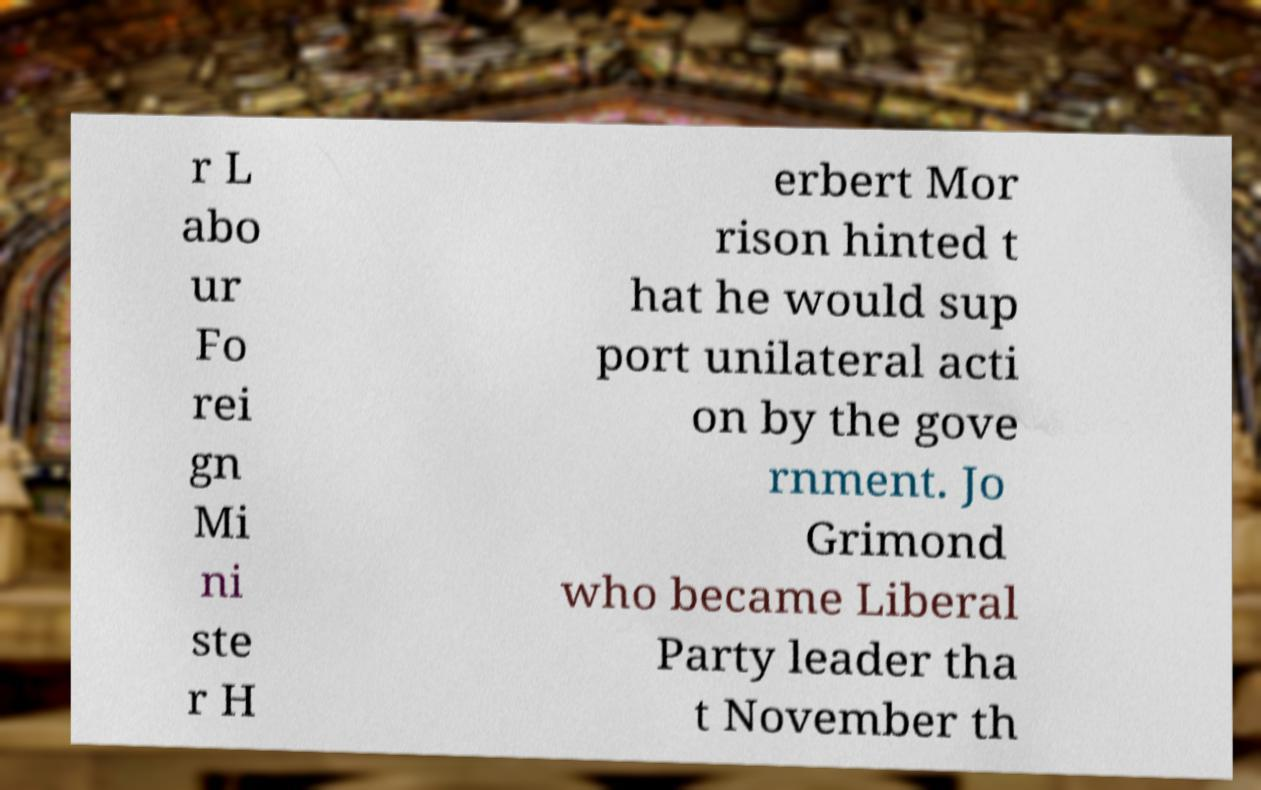Can you accurately transcribe the text from the provided image for me? r L abo ur Fo rei gn Mi ni ste r H erbert Mor rison hinted t hat he would sup port unilateral acti on by the gove rnment. Jo Grimond who became Liberal Party leader tha t November th 